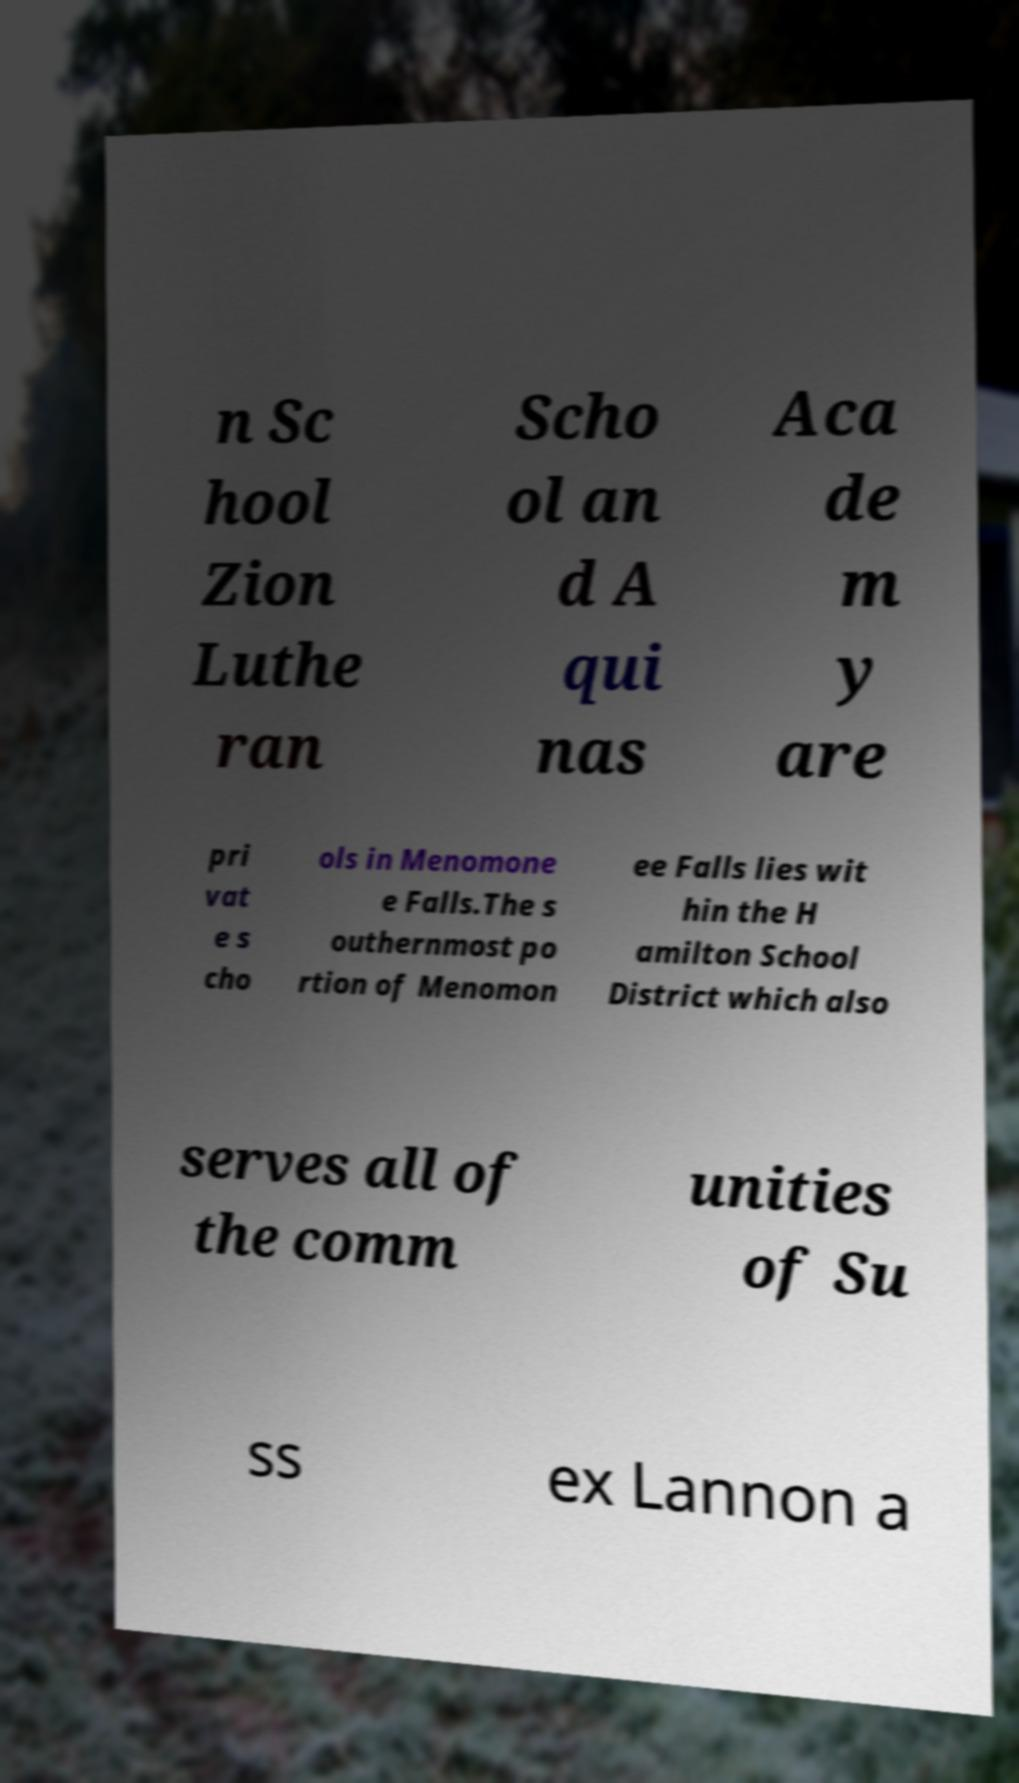I need the written content from this picture converted into text. Can you do that? n Sc hool Zion Luthe ran Scho ol an d A qui nas Aca de m y are pri vat e s cho ols in Menomone e Falls.The s outhernmost po rtion of Menomon ee Falls lies wit hin the H amilton School District which also serves all of the comm unities of Su ss ex Lannon a 